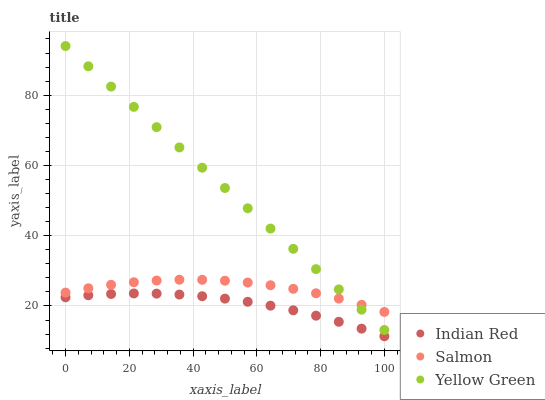Does Indian Red have the minimum area under the curve?
Answer yes or no. Yes. Does Yellow Green have the maximum area under the curve?
Answer yes or no. Yes. Does Yellow Green have the minimum area under the curve?
Answer yes or no. No. Does Indian Red have the maximum area under the curve?
Answer yes or no. No. Is Yellow Green the smoothest?
Answer yes or no. Yes. Is Salmon the roughest?
Answer yes or no. Yes. Is Indian Red the smoothest?
Answer yes or no. No. Is Indian Red the roughest?
Answer yes or no. No. Does Indian Red have the lowest value?
Answer yes or no. Yes. Does Yellow Green have the lowest value?
Answer yes or no. No. Does Yellow Green have the highest value?
Answer yes or no. Yes. Does Indian Red have the highest value?
Answer yes or no. No. Is Indian Red less than Salmon?
Answer yes or no. Yes. Is Yellow Green greater than Indian Red?
Answer yes or no. Yes. Does Yellow Green intersect Salmon?
Answer yes or no. Yes. Is Yellow Green less than Salmon?
Answer yes or no. No. Is Yellow Green greater than Salmon?
Answer yes or no. No. Does Indian Red intersect Salmon?
Answer yes or no. No. 